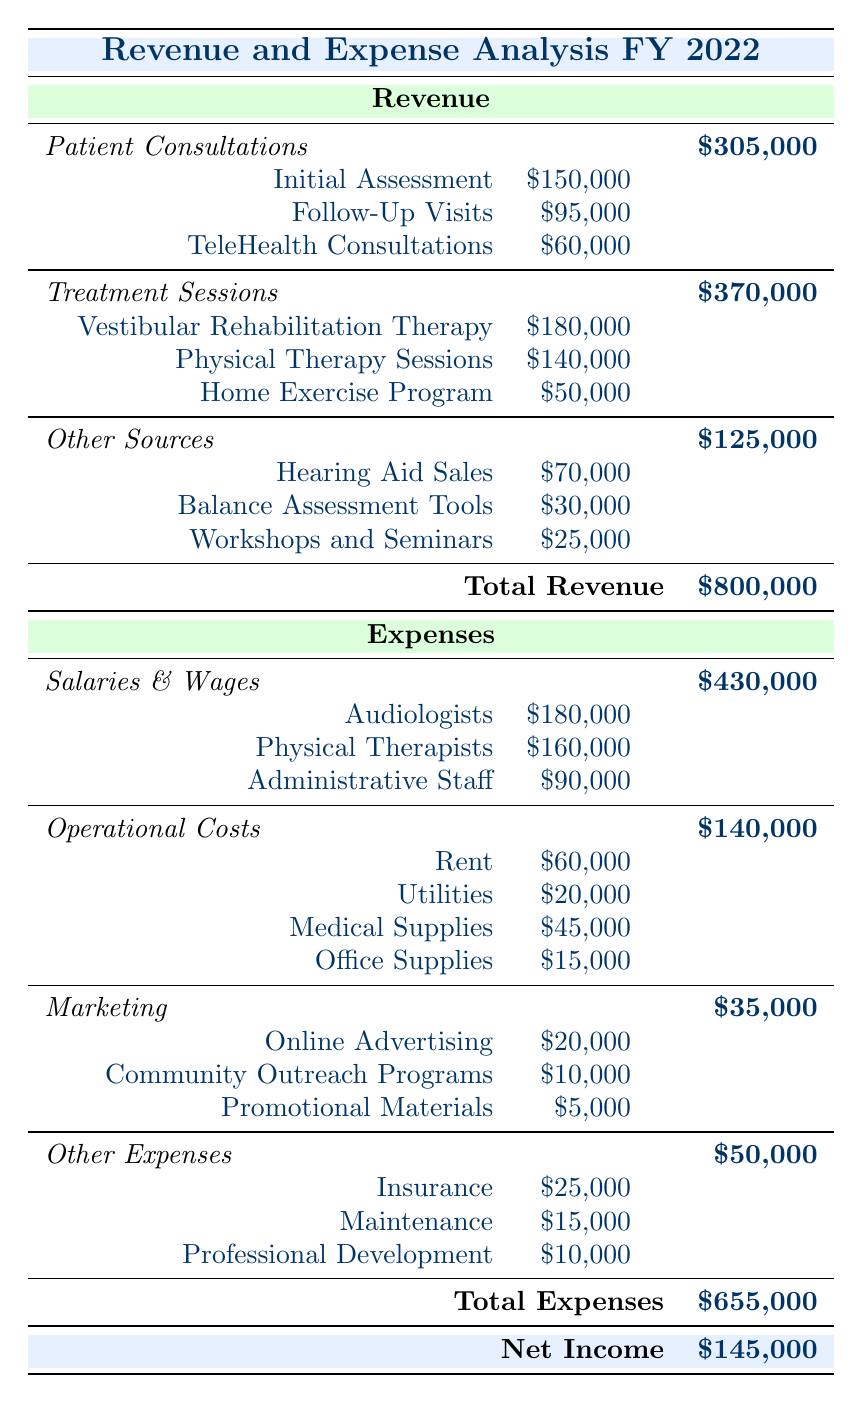What is the total revenue generated from patient consultations? The total revenue from patient consultations can be found under the "Patient Consultations" section in the revenue table. Adding the three entries together: Initial Assessment ($150,000) + Follow-Up Visits ($95,000) + TeleHealth Consultations ($60,000) gives us $305,000.
Answer: 305000 What is the total expense for salaries and wages? To find the total expense for salaries and wages, we need to sum the salaries of the three types of staff: Audiologists ($180,000) + Physical Therapists ($160,000) + Administrative Staff ($90,000). This results in $430,000, which is stated in the expenses section.
Answer: 430000 Are the total revenues higher than the total expenses? The total revenue is $800,000 and the total expenses are $655,000. Since $800,000 is greater than $655,000, the statement is true.
Answer: Yes What is the net income for the clinic in FY 2022? The net income can be found by subtracting the total expenses from the total revenue. This is calculated as $800,000 (Total Revenue) - $655,000 (Total Expenses) = $145,000. This figure is also presented in the final row of the table under "Net Income."
Answer: 145000 How much was spent on operational costs compared to marketing expenses? First, the total operational costs are found: Rent ($60,000) + Utilities ($20,000) + Medical Supplies ($45,000) + Office Supplies ($15,000) = $140,000. For marketing, the total is: Online Advertising ($20,000) + Community Outreach Programs ($10,000) + Promotional Materials ($5,000) = $35,000. Comparing these, $140,000 (operational costs) is significantly higher than $35,000 (marketing expenses).
Answer: 140000 What is the percentage contribution of Hearing Aid Sales to the total revenue? Hearing Aid Sales generate $70,000. The total revenue is $800,000. To find the percentage contribution, we calculate ($70,000 / $800,000) * 100 = 8.75%.
Answer: 8.75 What is the total revenue from treatment sessions? To calculate the total revenue from treatment sessions, we sum the three categories: Vestibular Rehabilitation Therapy ($180,000) + Physical Therapy Sessions ($140,000) + Home Exercise Program ($50,000). This equals $370,000, which is listed in the revenue section.
Answer: 370000 Is the expense for insurance higher than the cost of promotional materials? The expense for insurance is $25,000, while the cost of promotional materials is $5,000. Since $25,000 is greater than $5,000, the statement is true.
Answer: Yes 